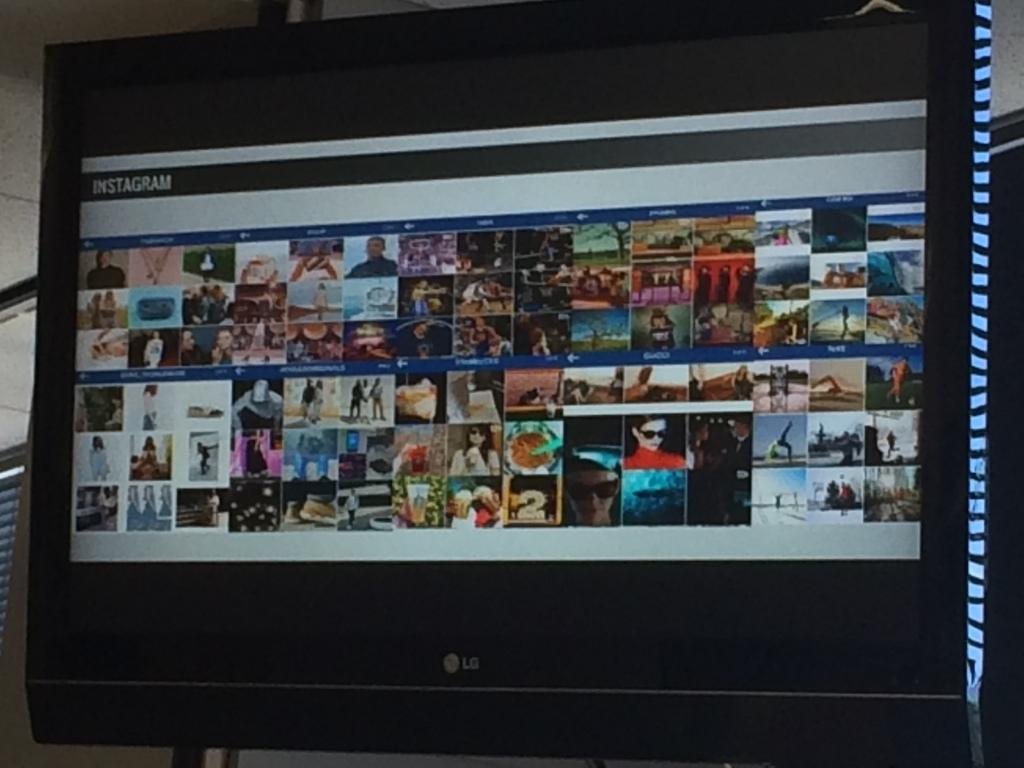<image>
Share a concise interpretation of the image provided. An LG branded monitor with a collage of different pictures on it. 